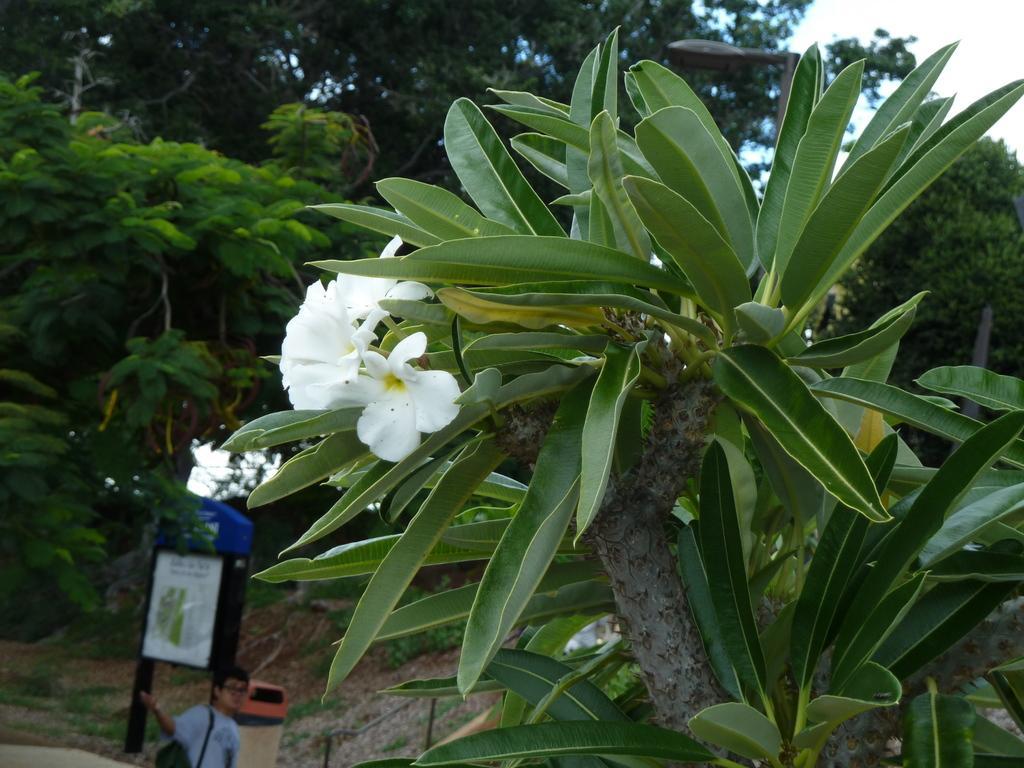Can you describe this image briefly? In this picture there are white color flowers on the plant. On the left side of the image there is a person standing and there is a board on the pole and there is text on the board. At the back there are trees. At the top there is sky. At the bottom there is grass and there is ground. Behind the tree there is a street light and there might be a railing. 